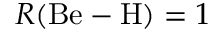Convert formula to latex. <formula><loc_0><loc_0><loc_500><loc_500>R ( B e - H ) = 1</formula> 